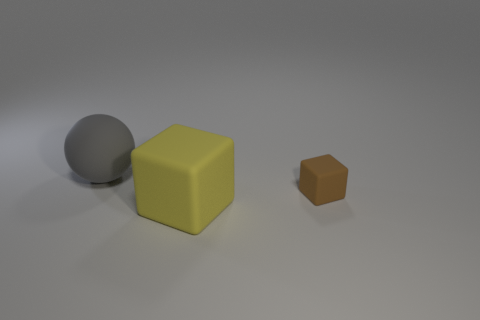Add 2 large gray rubber objects. How many objects exist? 5 Subtract all yellow cubes. How many cubes are left? 1 Subtract 1 balls. How many balls are left? 0 Subtract all spheres. How many objects are left? 2 Add 1 yellow rubber cubes. How many yellow rubber cubes are left? 2 Add 1 small cubes. How many small cubes exist? 2 Subtract 0 red spheres. How many objects are left? 3 Subtract all gray blocks. Subtract all red cylinders. How many blocks are left? 2 Subtract all large yellow rubber blocks. Subtract all gray matte balls. How many objects are left? 1 